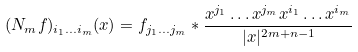<formula> <loc_0><loc_0><loc_500><loc_500>( N _ { m } f ) _ { i _ { 1 } \dots i _ { m } } ( x ) = f _ { j _ { 1 } \dots j _ { m } } * \frac { x ^ { j _ { 1 } } \dots x ^ { j _ { m } } x ^ { i _ { 1 } } \dots x ^ { i _ { m } } } { | x | ^ { 2 m + n - 1 } }</formula> 